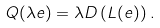Convert formula to latex. <formula><loc_0><loc_0><loc_500><loc_500>Q ( \lambda e ) = \lambda D \left ( L ( e ) \right ) .</formula> 